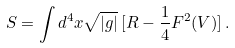Convert formula to latex. <formula><loc_0><loc_0><loc_500><loc_500>S = \int d ^ { 4 } x \sqrt { | g | } \, [ R - { \frac { 1 } { 4 } } F ^ { 2 } ( V ) ] \, .</formula> 